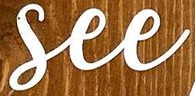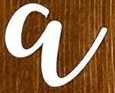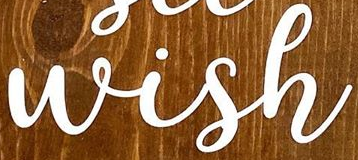What text appears in these images from left to right, separated by a semicolon? See; a; Wish 